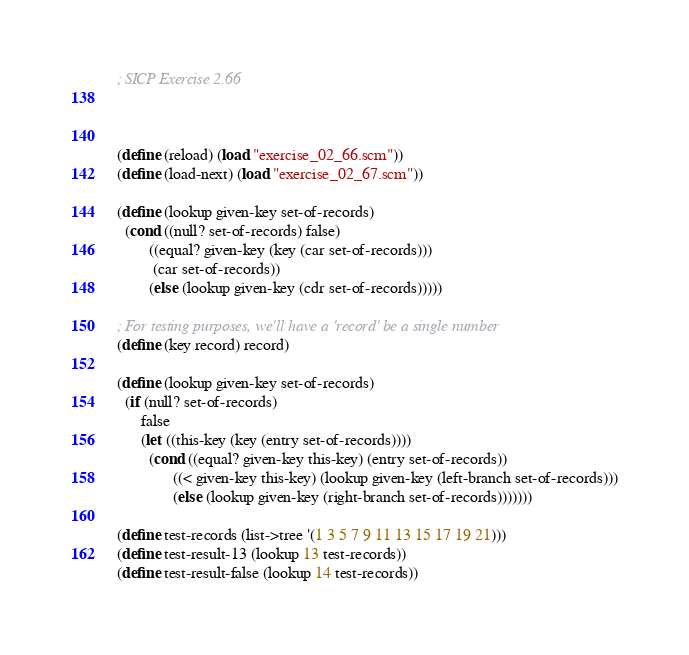Convert code to text. <code><loc_0><loc_0><loc_500><loc_500><_Scheme_>; SICP Exercise 2.66



(define (reload) (load "exercise_02_66.scm"))
(define (load-next) (load "exercise_02_67.scm"))

(define (lookup given-key set-of-records)
  (cond ((null? set-of-records) false)
        ((equal? given-key (key (car set-of-records)))
         (car set-of-records))
        (else (lookup given-key (cdr set-of-records)))))

; For testing purposes, we'll have a 'record' be a single number
(define (key record) record)

(define (lookup given-key set-of-records)
  (if (null? set-of-records)
      false
      (let ((this-key (key (entry set-of-records))))
        (cond ((equal? given-key this-key) (entry set-of-records))
              ((< given-key this-key) (lookup given-key (left-branch set-of-records)))
              (else (lookup given-key (right-branch set-of-records)))))))

(define test-records (list->tree '(1 3 5 7 9 11 13 15 17 19 21)))
(define test-result-13 (lookup 13 test-records))
(define test-result-false (lookup 14 test-records))
</code> 